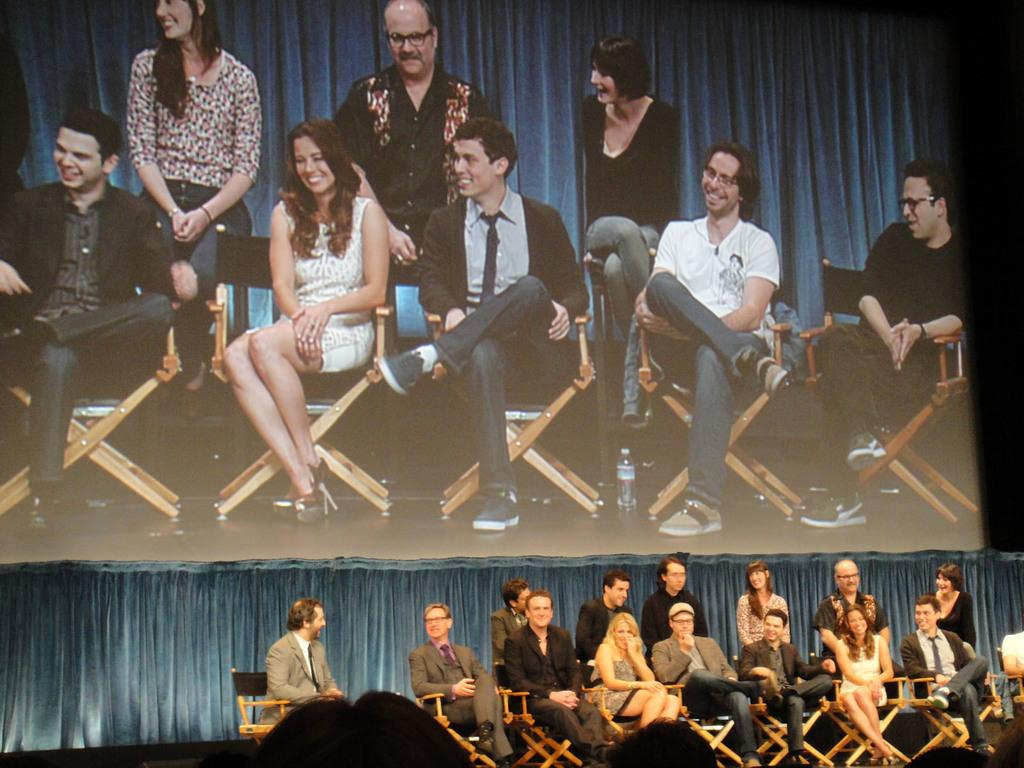How many people are in the image? There is a group of people in the image. What are some of the people in the image doing? Some people are sitting on the people in the image are sitting on chairs. What can be seen on the right side of the image? There is an object on the right side of the image. What is visible in the background of the image? There is a curtain and a screen in the background of the image. What type of pancake is the farmer coughing up in the image? There is no pancake or farmer present in the image, and no one is coughing. 